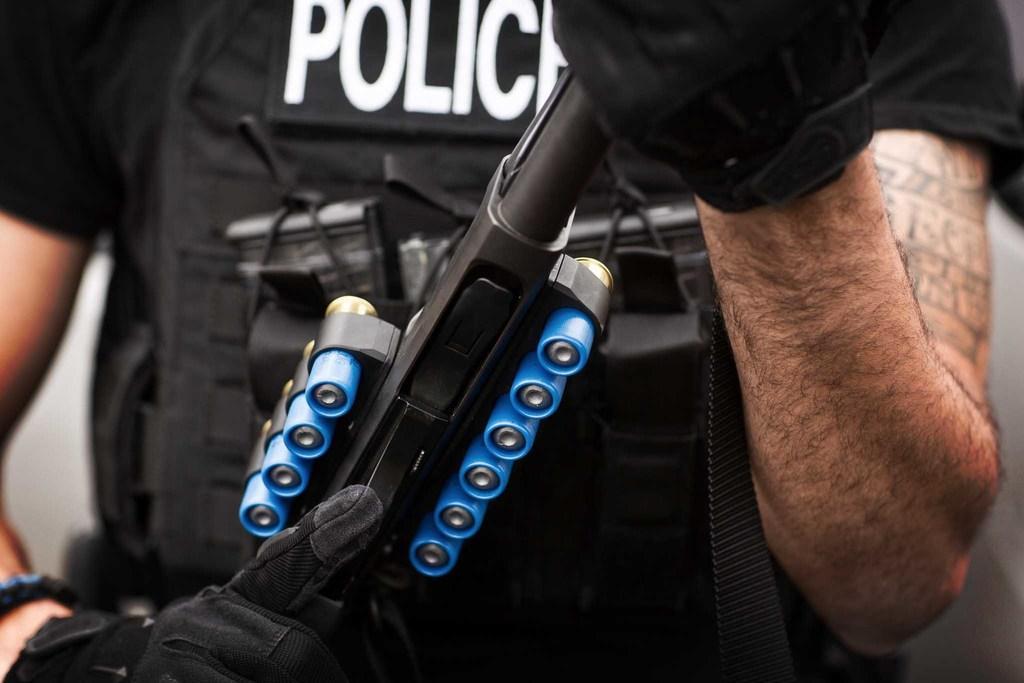Can you describe this image briefly? In this picture there is a cop in the center of the image, by holding a gun in his hands. 